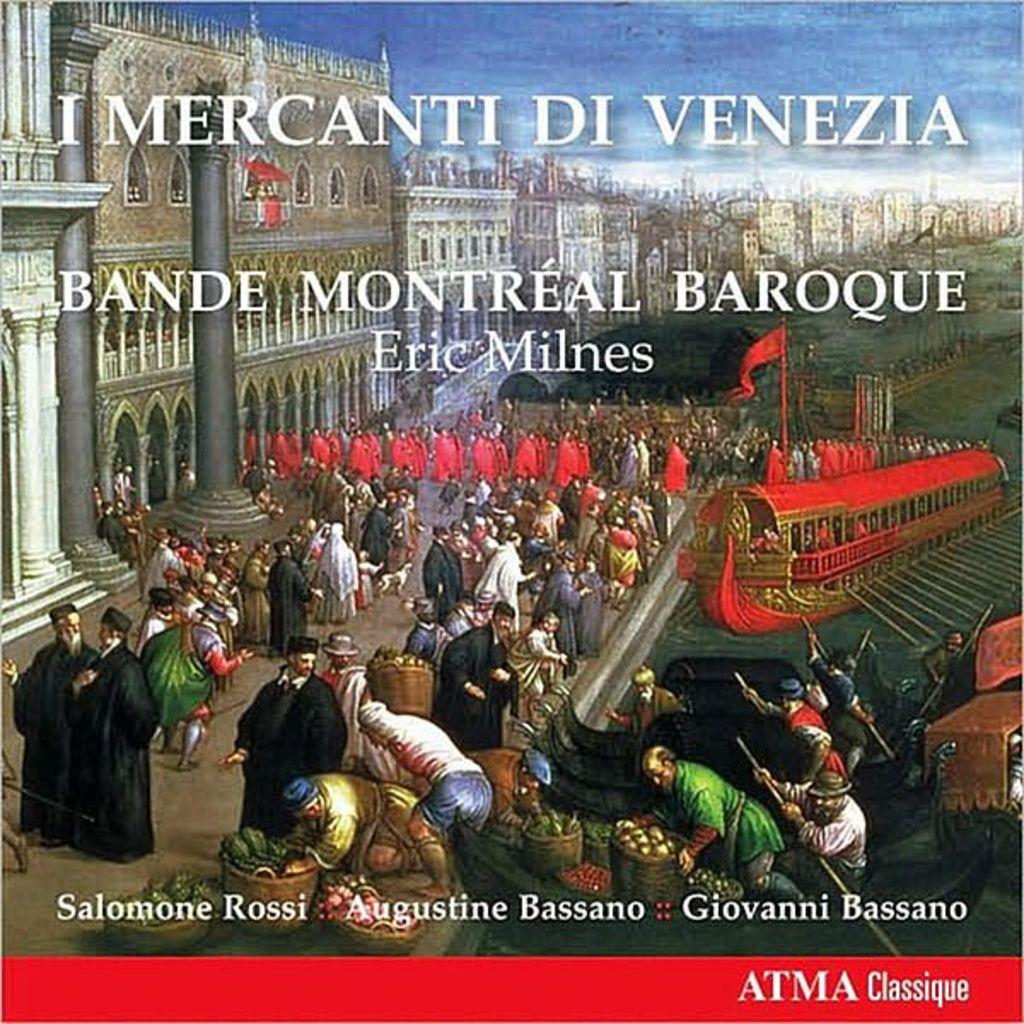Who is the creator of this classic piece from montreal?
Your response must be concise. Eric milnes. 